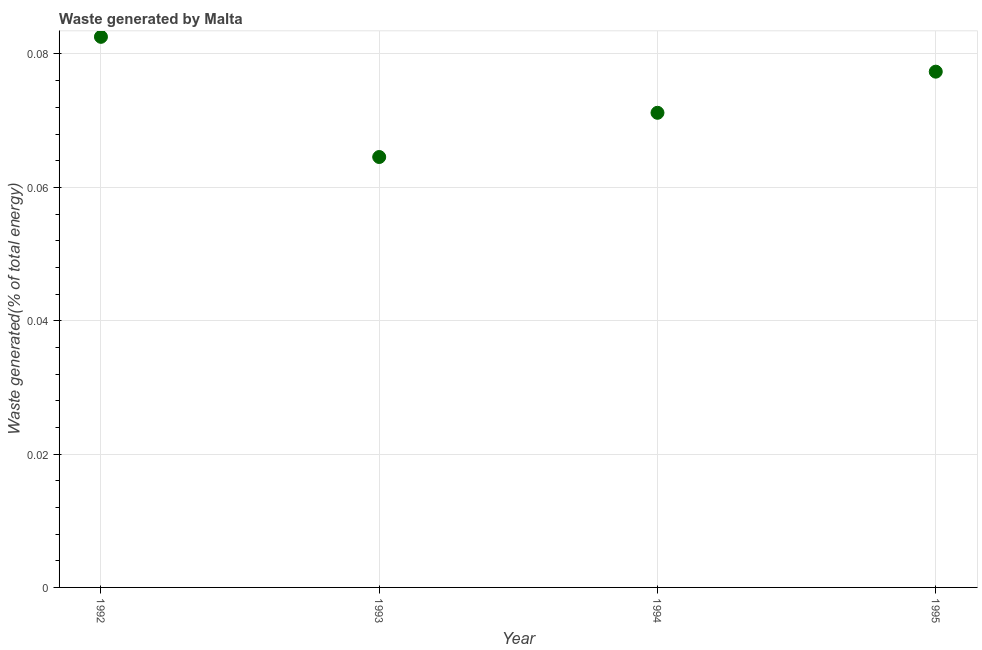What is the amount of waste generated in 1995?
Provide a succinct answer. 0.08. Across all years, what is the maximum amount of waste generated?
Provide a short and direct response. 0.08. Across all years, what is the minimum amount of waste generated?
Ensure brevity in your answer.  0.06. In which year was the amount of waste generated maximum?
Make the answer very short. 1992. In which year was the amount of waste generated minimum?
Keep it short and to the point. 1993. What is the sum of the amount of waste generated?
Your answer should be compact. 0.3. What is the difference between the amount of waste generated in 1993 and 1995?
Offer a very short reply. -0.01. What is the average amount of waste generated per year?
Your answer should be very brief. 0.07. What is the median amount of waste generated?
Provide a succinct answer. 0.07. What is the ratio of the amount of waste generated in 1992 to that in 1995?
Your answer should be compact. 1.07. Is the difference between the amount of waste generated in 1992 and 1993 greater than the difference between any two years?
Provide a succinct answer. Yes. What is the difference between the highest and the second highest amount of waste generated?
Ensure brevity in your answer.  0.01. Is the sum of the amount of waste generated in 1994 and 1995 greater than the maximum amount of waste generated across all years?
Offer a terse response. Yes. What is the difference between the highest and the lowest amount of waste generated?
Provide a short and direct response. 0.02. Does the amount of waste generated monotonically increase over the years?
Offer a very short reply. No. How many dotlines are there?
Your answer should be very brief. 1. Are the values on the major ticks of Y-axis written in scientific E-notation?
Your response must be concise. No. Does the graph contain any zero values?
Give a very brief answer. No. What is the title of the graph?
Ensure brevity in your answer.  Waste generated by Malta. What is the label or title of the Y-axis?
Offer a terse response. Waste generated(% of total energy). What is the Waste generated(% of total energy) in 1992?
Give a very brief answer. 0.08. What is the Waste generated(% of total energy) in 1993?
Offer a very short reply. 0.06. What is the Waste generated(% of total energy) in 1994?
Your answer should be very brief. 0.07. What is the Waste generated(% of total energy) in 1995?
Offer a very short reply. 0.08. What is the difference between the Waste generated(% of total energy) in 1992 and 1993?
Offer a very short reply. 0.02. What is the difference between the Waste generated(% of total energy) in 1992 and 1994?
Your answer should be compact. 0.01. What is the difference between the Waste generated(% of total energy) in 1992 and 1995?
Offer a terse response. 0.01. What is the difference between the Waste generated(% of total energy) in 1993 and 1994?
Your answer should be compact. -0.01. What is the difference between the Waste generated(% of total energy) in 1993 and 1995?
Provide a succinct answer. -0.01. What is the difference between the Waste generated(% of total energy) in 1994 and 1995?
Keep it short and to the point. -0.01. What is the ratio of the Waste generated(% of total energy) in 1992 to that in 1993?
Provide a short and direct response. 1.28. What is the ratio of the Waste generated(% of total energy) in 1992 to that in 1994?
Provide a succinct answer. 1.16. What is the ratio of the Waste generated(% of total energy) in 1992 to that in 1995?
Ensure brevity in your answer.  1.07. What is the ratio of the Waste generated(% of total energy) in 1993 to that in 1994?
Your answer should be compact. 0.91. What is the ratio of the Waste generated(% of total energy) in 1993 to that in 1995?
Offer a very short reply. 0.83. 